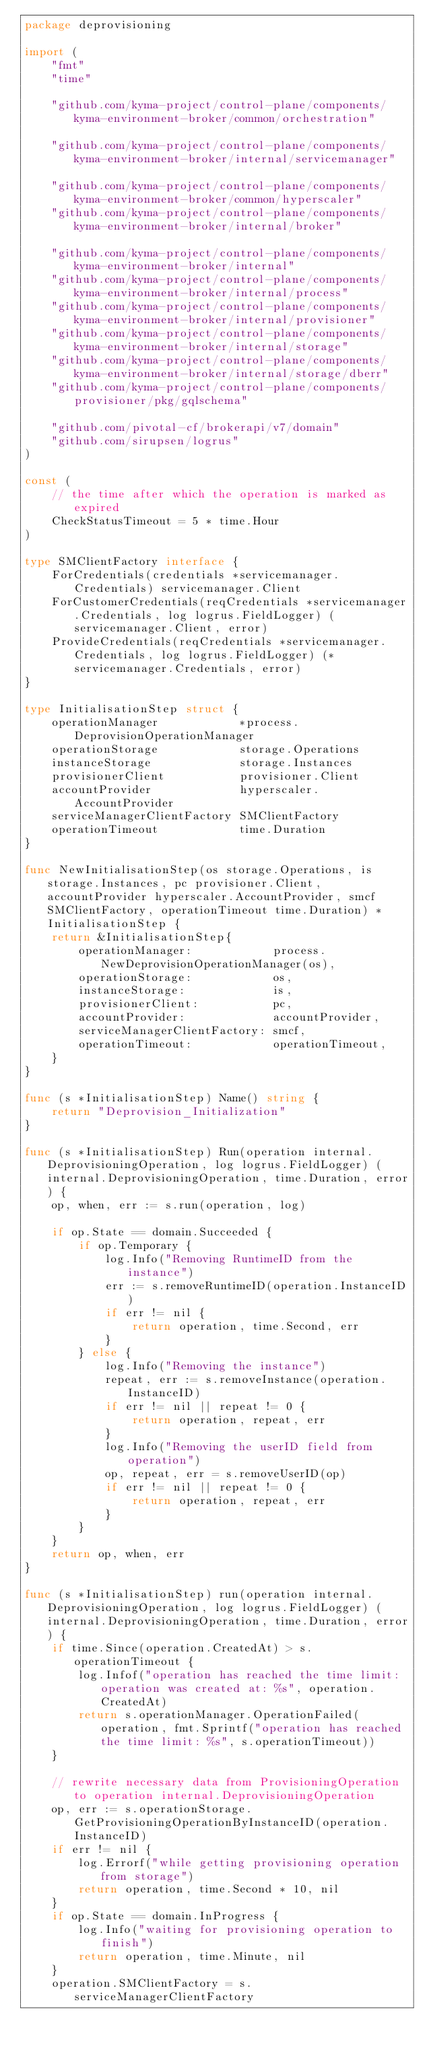<code> <loc_0><loc_0><loc_500><loc_500><_Go_>package deprovisioning

import (
	"fmt"
	"time"

	"github.com/kyma-project/control-plane/components/kyma-environment-broker/common/orchestration"

	"github.com/kyma-project/control-plane/components/kyma-environment-broker/internal/servicemanager"

	"github.com/kyma-project/control-plane/components/kyma-environment-broker/common/hyperscaler"
	"github.com/kyma-project/control-plane/components/kyma-environment-broker/internal/broker"

	"github.com/kyma-project/control-plane/components/kyma-environment-broker/internal"
	"github.com/kyma-project/control-plane/components/kyma-environment-broker/internal/process"
	"github.com/kyma-project/control-plane/components/kyma-environment-broker/internal/provisioner"
	"github.com/kyma-project/control-plane/components/kyma-environment-broker/internal/storage"
	"github.com/kyma-project/control-plane/components/kyma-environment-broker/internal/storage/dberr"
	"github.com/kyma-project/control-plane/components/provisioner/pkg/gqlschema"

	"github.com/pivotal-cf/brokerapi/v7/domain"
	"github.com/sirupsen/logrus"
)

const (
	// the time after which the operation is marked as expired
	CheckStatusTimeout = 5 * time.Hour
)

type SMClientFactory interface {
	ForCredentials(credentials *servicemanager.Credentials) servicemanager.Client
	ForCustomerCredentials(reqCredentials *servicemanager.Credentials, log logrus.FieldLogger) (servicemanager.Client, error)
	ProvideCredentials(reqCredentials *servicemanager.Credentials, log logrus.FieldLogger) (*servicemanager.Credentials, error)
}

type InitialisationStep struct {
	operationManager            *process.DeprovisionOperationManager
	operationStorage            storage.Operations
	instanceStorage             storage.Instances
	provisionerClient           provisioner.Client
	accountProvider             hyperscaler.AccountProvider
	serviceManagerClientFactory SMClientFactory
	operationTimeout            time.Duration
}

func NewInitialisationStep(os storage.Operations, is storage.Instances, pc provisioner.Client, accountProvider hyperscaler.AccountProvider, smcf SMClientFactory, operationTimeout time.Duration) *InitialisationStep {
	return &InitialisationStep{
		operationManager:            process.NewDeprovisionOperationManager(os),
		operationStorage:            os,
		instanceStorage:             is,
		provisionerClient:           pc,
		accountProvider:             accountProvider,
		serviceManagerClientFactory: smcf,
		operationTimeout:            operationTimeout,
	}
}

func (s *InitialisationStep) Name() string {
	return "Deprovision_Initialization"
}

func (s *InitialisationStep) Run(operation internal.DeprovisioningOperation, log logrus.FieldLogger) (internal.DeprovisioningOperation, time.Duration, error) {
	op, when, err := s.run(operation, log)

	if op.State == domain.Succeeded {
		if op.Temporary {
			log.Info("Removing RuntimeID from the instance")
			err := s.removeRuntimeID(operation.InstanceID)
			if err != nil {
				return operation, time.Second, err
			}
		} else {
			log.Info("Removing the instance")
			repeat, err := s.removeInstance(operation.InstanceID)
			if err != nil || repeat != 0 {
				return operation, repeat, err
			}
			log.Info("Removing the userID field from operation")
			op, repeat, err = s.removeUserID(op)
			if err != nil || repeat != 0 {
				return operation, repeat, err
			}
		}
	}
	return op, when, err
}

func (s *InitialisationStep) run(operation internal.DeprovisioningOperation, log logrus.FieldLogger) (internal.DeprovisioningOperation, time.Duration, error) {
	if time.Since(operation.CreatedAt) > s.operationTimeout {
		log.Infof("operation has reached the time limit: operation was created at: %s", operation.CreatedAt)
		return s.operationManager.OperationFailed(operation, fmt.Sprintf("operation has reached the time limit: %s", s.operationTimeout))
	}

	// rewrite necessary data from ProvisioningOperation to operation internal.DeprovisioningOperation
	op, err := s.operationStorage.GetProvisioningOperationByInstanceID(operation.InstanceID)
	if err != nil {
		log.Errorf("while getting provisioning operation from storage")
		return operation, time.Second * 10, nil
	}
	if op.State == domain.InProgress {
		log.Info("waiting for provisioning operation to finish")
		return operation, time.Minute, nil
	}
	operation.SMClientFactory = s.serviceManagerClientFactory
</code> 